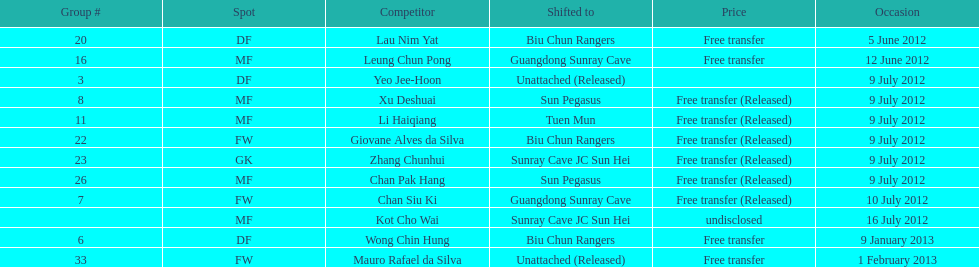Can you parse all the data within this table? {'header': ['Group #', 'Spot', 'Competitor', 'Shifted to', 'Price', 'Occasion'], 'rows': [['20', 'DF', 'Lau Nim Yat', 'Biu Chun Rangers', 'Free transfer', '5 June 2012'], ['16', 'MF', 'Leung Chun Pong', 'Guangdong Sunray Cave', 'Free transfer', '12 June 2012'], ['3', 'DF', 'Yeo Jee-Hoon', 'Unattached (Released)', '', '9 July 2012'], ['8', 'MF', 'Xu Deshuai', 'Sun Pegasus', 'Free transfer (Released)', '9 July 2012'], ['11', 'MF', 'Li Haiqiang', 'Tuen Mun', 'Free transfer (Released)', '9 July 2012'], ['22', 'FW', 'Giovane Alves da Silva', 'Biu Chun Rangers', 'Free transfer (Released)', '9 July 2012'], ['23', 'GK', 'Zhang Chunhui', 'Sunray Cave JC Sun Hei', 'Free transfer (Released)', '9 July 2012'], ['26', 'MF', 'Chan Pak Hang', 'Sun Pegasus', 'Free transfer (Released)', '9 July 2012'], ['7', 'FW', 'Chan Siu Ki', 'Guangdong Sunray Cave', 'Free transfer (Released)', '10 July 2012'], ['', 'MF', 'Kot Cho Wai', 'Sunray Cave JC Sun Hei', 'undisclosed', '16 July 2012'], ['6', 'DF', 'Wong Chin Hung', 'Biu Chun Rangers', 'Free transfer', '9 January 2013'], ['33', 'FW', 'Mauro Rafael da Silva', 'Unattached (Released)', 'Free transfer', '1 February 2013']]} Wong chin hung was transferred to his new team on what date? 9 January 2013. 